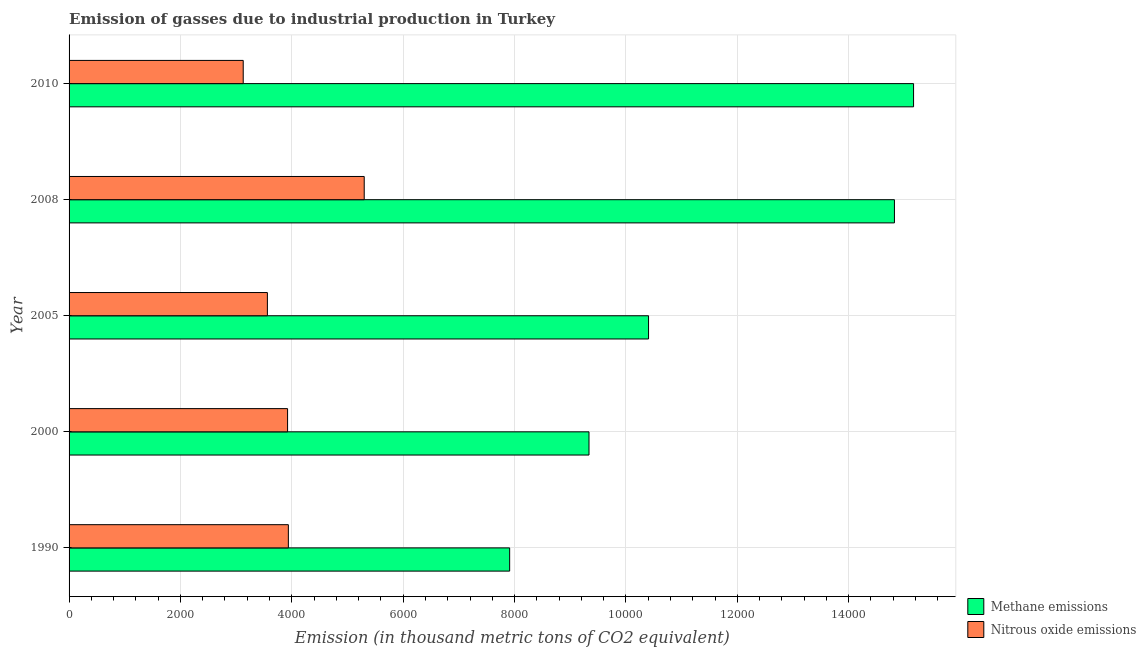How many different coloured bars are there?
Your response must be concise. 2. How many groups of bars are there?
Your answer should be compact. 5. Are the number of bars on each tick of the Y-axis equal?
Offer a terse response. Yes. How many bars are there on the 4th tick from the top?
Your answer should be compact. 2. In how many cases, is the number of bars for a given year not equal to the number of legend labels?
Your answer should be compact. 0. What is the amount of nitrous oxide emissions in 2010?
Your response must be concise. 3127.4. Across all years, what is the maximum amount of methane emissions?
Your answer should be compact. 1.52e+04. Across all years, what is the minimum amount of nitrous oxide emissions?
Ensure brevity in your answer.  3127.4. What is the total amount of nitrous oxide emissions in the graph?
Your answer should be very brief. 1.99e+04. What is the difference between the amount of methane emissions in 2008 and that in 2010?
Make the answer very short. -343.5. What is the difference between the amount of nitrous oxide emissions in 2008 and the amount of methane emissions in 1990?
Make the answer very short. -2611.8. What is the average amount of nitrous oxide emissions per year?
Keep it short and to the point. 3970.22. In the year 2005, what is the difference between the amount of methane emissions and amount of nitrous oxide emissions?
Your answer should be very brief. 6845. In how many years, is the amount of methane emissions greater than 6000 thousand metric tons?
Provide a short and direct response. 5. What is the ratio of the amount of methane emissions in 2005 to that in 2010?
Give a very brief answer. 0.69. Is the amount of nitrous oxide emissions in 1990 less than that in 2010?
Your answer should be very brief. No. What is the difference between the highest and the second highest amount of methane emissions?
Give a very brief answer. 343.5. What is the difference between the highest and the lowest amount of nitrous oxide emissions?
Offer a terse response. 2172.9. What does the 1st bar from the top in 2008 represents?
Your response must be concise. Nitrous oxide emissions. What does the 1st bar from the bottom in 2005 represents?
Provide a succinct answer. Methane emissions. How many bars are there?
Ensure brevity in your answer.  10. How many years are there in the graph?
Make the answer very short. 5. What is the difference between two consecutive major ticks on the X-axis?
Your answer should be very brief. 2000. Does the graph contain any zero values?
Keep it short and to the point. No. Does the graph contain grids?
Provide a short and direct response. Yes. Where does the legend appear in the graph?
Your response must be concise. Bottom right. How many legend labels are there?
Make the answer very short. 2. How are the legend labels stacked?
Your response must be concise. Vertical. What is the title of the graph?
Provide a short and direct response. Emission of gasses due to industrial production in Turkey. Does "Manufacturing industries and construction" appear as one of the legend labels in the graph?
Ensure brevity in your answer.  No. What is the label or title of the X-axis?
Your answer should be compact. Emission (in thousand metric tons of CO2 equivalent). What is the Emission (in thousand metric tons of CO2 equivalent) in Methane emissions in 1990?
Your answer should be compact. 7912.1. What is the Emission (in thousand metric tons of CO2 equivalent) in Nitrous oxide emissions in 1990?
Ensure brevity in your answer.  3938.1. What is the Emission (in thousand metric tons of CO2 equivalent) in Methane emissions in 2000?
Provide a short and direct response. 9337. What is the Emission (in thousand metric tons of CO2 equivalent) of Nitrous oxide emissions in 2000?
Give a very brief answer. 3923.9. What is the Emission (in thousand metric tons of CO2 equivalent) of Methane emissions in 2005?
Provide a succinct answer. 1.04e+04. What is the Emission (in thousand metric tons of CO2 equivalent) of Nitrous oxide emissions in 2005?
Offer a very short reply. 3561.4. What is the Emission (in thousand metric tons of CO2 equivalent) in Methane emissions in 2008?
Your response must be concise. 1.48e+04. What is the Emission (in thousand metric tons of CO2 equivalent) in Nitrous oxide emissions in 2008?
Your answer should be compact. 5300.3. What is the Emission (in thousand metric tons of CO2 equivalent) of Methane emissions in 2010?
Offer a terse response. 1.52e+04. What is the Emission (in thousand metric tons of CO2 equivalent) of Nitrous oxide emissions in 2010?
Offer a very short reply. 3127.4. Across all years, what is the maximum Emission (in thousand metric tons of CO2 equivalent) in Methane emissions?
Ensure brevity in your answer.  1.52e+04. Across all years, what is the maximum Emission (in thousand metric tons of CO2 equivalent) of Nitrous oxide emissions?
Keep it short and to the point. 5300.3. Across all years, what is the minimum Emission (in thousand metric tons of CO2 equivalent) of Methane emissions?
Your response must be concise. 7912.1. Across all years, what is the minimum Emission (in thousand metric tons of CO2 equivalent) in Nitrous oxide emissions?
Your answer should be compact. 3127.4. What is the total Emission (in thousand metric tons of CO2 equivalent) of Methane emissions in the graph?
Your response must be concise. 5.76e+04. What is the total Emission (in thousand metric tons of CO2 equivalent) of Nitrous oxide emissions in the graph?
Offer a terse response. 1.99e+04. What is the difference between the Emission (in thousand metric tons of CO2 equivalent) in Methane emissions in 1990 and that in 2000?
Provide a short and direct response. -1424.9. What is the difference between the Emission (in thousand metric tons of CO2 equivalent) of Nitrous oxide emissions in 1990 and that in 2000?
Your answer should be very brief. 14.2. What is the difference between the Emission (in thousand metric tons of CO2 equivalent) of Methane emissions in 1990 and that in 2005?
Your answer should be very brief. -2494.3. What is the difference between the Emission (in thousand metric tons of CO2 equivalent) in Nitrous oxide emissions in 1990 and that in 2005?
Offer a terse response. 376.7. What is the difference between the Emission (in thousand metric tons of CO2 equivalent) in Methane emissions in 1990 and that in 2008?
Offer a very short reply. -6910. What is the difference between the Emission (in thousand metric tons of CO2 equivalent) in Nitrous oxide emissions in 1990 and that in 2008?
Your answer should be compact. -1362.2. What is the difference between the Emission (in thousand metric tons of CO2 equivalent) in Methane emissions in 1990 and that in 2010?
Provide a succinct answer. -7253.5. What is the difference between the Emission (in thousand metric tons of CO2 equivalent) in Nitrous oxide emissions in 1990 and that in 2010?
Provide a short and direct response. 810.7. What is the difference between the Emission (in thousand metric tons of CO2 equivalent) of Methane emissions in 2000 and that in 2005?
Offer a very short reply. -1069.4. What is the difference between the Emission (in thousand metric tons of CO2 equivalent) of Nitrous oxide emissions in 2000 and that in 2005?
Your response must be concise. 362.5. What is the difference between the Emission (in thousand metric tons of CO2 equivalent) of Methane emissions in 2000 and that in 2008?
Offer a terse response. -5485.1. What is the difference between the Emission (in thousand metric tons of CO2 equivalent) of Nitrous oxide emissions in 2000 and that in 2008?
Your answer should be compact. -1376.4. What is the difference between the Emission (in thousand metric tons of CO2 equivalent) of Methane emissions in 2000 and that in 2010?
Give a very brief answer. -5828.6. What is the difference between the Emission (in thousand metric tons of CO2 equivalent) of Nitrous oxide emissions in 2000 and that in 2010?
Provide a succinct answer. 796.5. What is the difference between the Emission (in thousand metric tons of CO2 equivalent) of Methane emissions in 2005 and that in 2008?
Ensure brevity in your answer.  -4415.7. What is the difference between the Emission (in thousand metric tons of CO2 equivalent) in Nitrous oxide emissions in 2005 and that in 2008?
Offer a terse response. -1738.9. What is the difference between the Emission (in thousand metric tons of CO2 equivalent) of Methane emissions in 2005 and that in 2010?
Ensure brevity in your answer.  -4759.2. What is the difference between the Emission (in thousand metric tons of CO2 equivalent) of Nitrous oxide emissions in 2005 and that in 2010?
Give a very brief answer. 434. What is the difference between the Emission (in thousand metric tons of CO2 equivalent) of Methane emissions in 2008 and that in 2010?
Your response must be concise. -343.5. What is the difference between the Emission (in thousand metric tons of CO2 equivalent) in Nitrous oxide emissions in 2008 and that in 2010?
Provide a succinct answer. 2172.9. What is the difference between the Emission (in thousand metric tons of CO2 equivalent) of Methane emissions in 1990 and the Emission (in thousand metric tons of CO2 equivalent) of Nitrous oxide emissions in 2000?
Make the answer very short. 3988.2. What is the difference between the Emission (in thousand metric tons of CO2 equivalent) in Methane emissions in 1990 and the Emission (in thousand metric tons of CO2 equivalent) in Nitrous oxide emissions in 2005?
Keep it short and to the point. 4350.7. What is the difference between the Emission (in thousand metric tons of CO2 equivalent) in Methane emissions in 1990 and the Emission (in thousand metric tons of CO2 equivalent) in Nitrous oxide emissions in 2008?
Provide a succinct answer. 2611.8. What is the difference between the Emission (in thousand metric tons of CO2 equivalent) of Methane emissions in 1990 and the Emission (in thousand metric tons of CO2 equivalent) of Nitrous oxide emissions in 2010?
Your response must be concise. 4784.7. What is the difference between the Emission (in thousand metric tons of CO2 equivalent) of Methane emissions in 2000 and the Emission (in thousand metric tons of CO2 equivalent) of Nitrous oxide emissions in 2005?
Offer a terse response. 5775.6. What is the difference between the Emission (in thousand metric tons of CO2 equivalent) of Methane emissions in 2000 and the Emission (in thousand metric tons of CO2 equivalent) of Nitrous oxide emissions in 2008?
Your answer should be very brief. 4036.7. What is the difference between the Emission (in thousand metric tons of CO2 equivalent) in Methane emissions in 2000 and the Emission (in thousand metric tons of CO2 equivalent) in Nitrous oxide emissions in 2010?
Your response must be concise. 6209.6. What is the difference between the Emission (in thousand metric tons of CO2 equivalent) in Methane emissions in 2005 and the Emission (in thousand metric tons of CO2 equivalent) in Nitrous oxide emissions in 2008?
Make the answer very short. 5106.1. What is the difference between the Emission (in thousand metric tons of CO2 equivalent) in Methane emissions in 2005 and the Emission (in thousand metric tons of CO2 equivalent) in Nitrous oxide emissions in 2010?
Your response must be concise. 7279. What is the difference between the Emission (in thousand metric tons of CO2 equivalent) in Methane emissions in 2008 and the Emission (in thousand metric tons of CO2 equivalent) in Nitrous oxide emissions in 2010?
Your answer should be very brief. 1.17e+04. What is the average Emission (in thousand metric tons of CO2 equivalent) of Methane emissions per year?
Ensure brevity in your answer.  1.15e+04. What is the average Emission (in thousand metric tons of CO2 equivalent) in Nitrous oxide emissions per year?
Keep it short and to the point. 3970.22. In the year 1990, what is the difference between the Emission (in thousand metric tons of CO2 equivalent) in Methane emissions and Emission (in thousand metric tons of CO2 equivalent) in Nitrous oxide emissions?
Offer a very short reply. 3974. In the year 2000, what is the difference between the Emission (in thousand metric tons of CO2 equivalent) in Methane emissions and Emission (in thousand metric tons of CO2 equivalent) in Nitrous oxide emissions?
Your answer should be compact. 5413.1. In the year 2005, what is the difference between the Emission (in thousand metric tons of CO2 equivalent) in Methane emissions and Emission (in thousand metric tons of CO2 equivalent) in Nitrous oxide emissions?
Your answer should be compact. 6845. In the year 2008, what is the difference between the Emission (in thousand metric tons of CO2 equivalent) in Methane emissions and Emission (in thousand metric tons of CO2 equivalent) in Nitrous oxide emissions?
Your answer should be compact. 9521.8. In the year 2010, what is the difference between the Emission (in thousand metric tons of CO2 equivalent) in Methane emissions and Emission (in thousand metric tons of CO2 equivalent) in Nitrous oxide emissions?
Offer a very short reply. 1.20e+04. What is the ratio of the Emission (in thousand metric tons of CO2 equivalent) in Methane emissions in 1990 to that in 2000?
Offer a very short reply. 0.85. What is the ratio of the Emission (in thousand metric tons of CO2 equivalent) in Methane emissions in 1990 to that in 2005?
Ensure brevity in your answer.  0.76. What is the ratio of the Emission (in thousand metric tons of CO2 equivalent) of Nitrous oxide emissions in 1990 to that in 2005?
Your answer should be very brief. 1.11. What is the ratio of the Emission (in thousand metric tons of CO2 equivalent) of Methane emissions in 1990 to that in 2008?
Your answer should be compact. 0.53. What is the ratio of the Emission (in thousand metric tons of CO2 equivalent) of Nitrous oxide emissions in 1990 to that in 2008?
Your answer should be very brief. 0.74. What is the ratio of the Emission (in thousand metric tons of CO2 equivalent) in Methane emissions in 1990 to that in 2010?
Offer a terse response. 0.52. What is the ratio of the Emission (in thousand metric tons of CO2 equivalent) of Nitrous oxide emissions in 1990 to that in 2010?
Make the answer very short. 1.26. What is the ratio of the Emission (in thousand metric tons of CO2 equivalent) in Methane emissions in 2000 to that in 2005?
Your answer should be very brief. 0.9. What is the ratio of the Emission (in thousand metric tons of CO2 equivalent) of Nitrous oxide emissions in 2000 to that in 2005?
Make the answer very short. 1.1. What is the ratio of the Emission (in thousand metric tons of CO2 equivalent) of Methane emissions in 2000 to that in 2008?
Keep it short and to the point. 0.63. What is the ratio of the Emission (in thousand metric tons of CO2 equivalent) of Nitrous oxide emissions in 2000 to that in 2008?
Keep it short and to the point. 0.74. What is the ratio of the Emission (in thousand metric tons of CO2 equivalent) in Methane emissions in 2000 to that in 2010?
Provide a succinct answer. 0.62. What is the ratio of the Emission (in thousand metric tons of CO2 equivalent) in Nitrous oxide emissions in 2000 to that in 2010?
Your answer should be very brief. 1.25. What is the ratio of the Emission (in thousand metric tons of CO2 equivalent) in Methane emissions in 2005 to that in 2008?
Give a very brief answer. 0.7. What is the ratio of the Emission (in thousand metric tons of CO2 equivalent) of Nitrous oxide emissions in 2005 to that in 2008?
Offer a very short reply. 0.67. What is the ratio of the Emission (in thousand metric tons of CO2 equivalent) in Methane emissions in 2005 to that in 2010?
Provide a succinct answer. 0.69. What is the ratio of the Emission (in thousand metric tons of CO2 equivalent) in Nitrous oxide emissions in 2005 to that in 2010?
Ensure brevity in your answer.  1.14. What is the ratio of the Emission (in thousand metric tons of CO2 equivalent) of Methane emissions in 2008 to that in 2010?
Offer a very short reply. 0.98. What is the ratio of the Emission (in thousand metric tons of CO2 equivalent) in Nitrous oxide emissions in 2008 to that in 2010?
Offer a terse response. 1.69. What is the difference between the highest and the second highest Emission (in thousand metric tons of CO2 equivalent) of Methane emissions?
Offer a terse response. 343.5. What is the difference between the highest and the second highest Emission (in thousand metric tons of CO2 equivalent) in Nitrous oxide emissions?
Provide a succinct answer. 1362.2. What is the difference between the highest and the lowest Emission (in thousand metric tons of CO2 equivalent) of Methane emissions?
Keep it short and to the point. 7253.5. What is the difference between the highest and the lowest Emission (in thousand metric tons of CO2 equivalent) in Nitrous oxide emissions?
Your answer should be compact. 2172.9. 